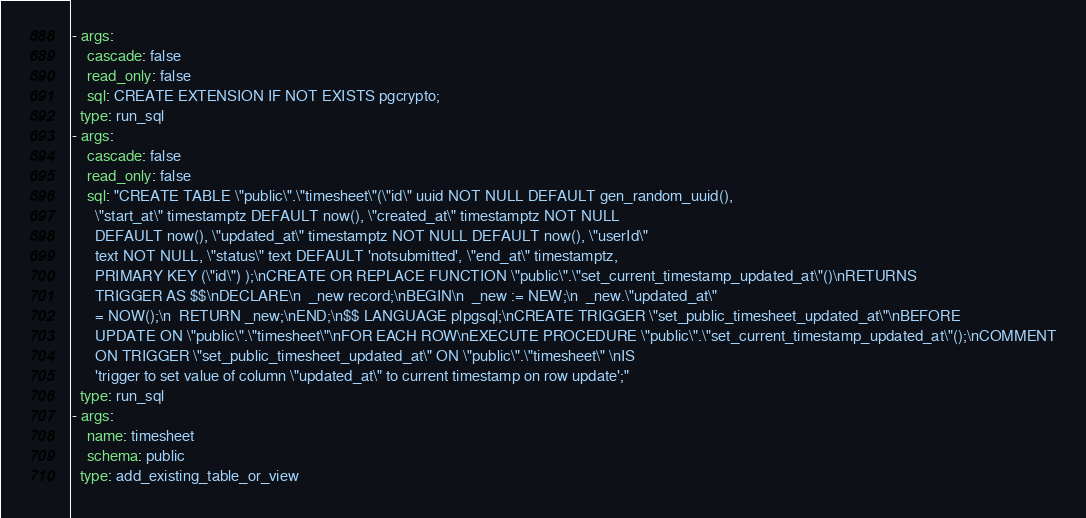<code> <loc_0><loc_0><loc_500><loc_500><_YAML_>- args:
    cascade: false
    read_only: false
    sql: CREATE EXTENSION IF NOT EXISTS pgcrypto;
  type: run_sql
- args:
    cascade: false
    read_only: false
    sql: "CREATE TABLE \"public\".\"timesheet\"(\"id\" uuid NOT NULL DEFAULT gen_random_uuid(),
      \"start_at\" timestamptz DEFAULT now(), \"created_at\" timestamptz NOT NULL
      DEFAULT now(), \"updated_at\" timestamptz NOT NULL DEFAULT now(), \"userId\"
      text NOT NULL, \"status\" text DEFAULT 'notsubmitted', \"end_at\" timestamptz,
      PRIMARY KEY (\"id\") );\nCREATE OR REPLACE FUNCTION \"public\".\"set_current_timestamp_updated_at\"()\nRETURNS
      TRIGGER AS $$\nDECLARE\n  _new record;\nBEGIN\n  _new := NEW;\n  _new.\"updated_at\"
      = NOW();\n  RETURN _new;\nEND;\n$$ LANGUAGE plpgsql;\nCREATE TRIGGER \"set_public_timesheet_updated_at\"\nBEFORE
      UPDATE ON \"public\".\"timesheet\"\nFOR EACH ROW\nEXECUTE PROCEDURE \"public\".\"set_current_timestamp_updated_at\"();\nCOMMENT
      ON TRIGGER \"set_public_timesheet_updated_at\" ON \"public\".\"timesheet\" \nIS
      'trigger to set value of column \"updated_at\" to current timestamp on row update';"
  type: run_sql
- args:
    name: timesheet
    schema: public
  type: add_existing_table_or_view
</code> 